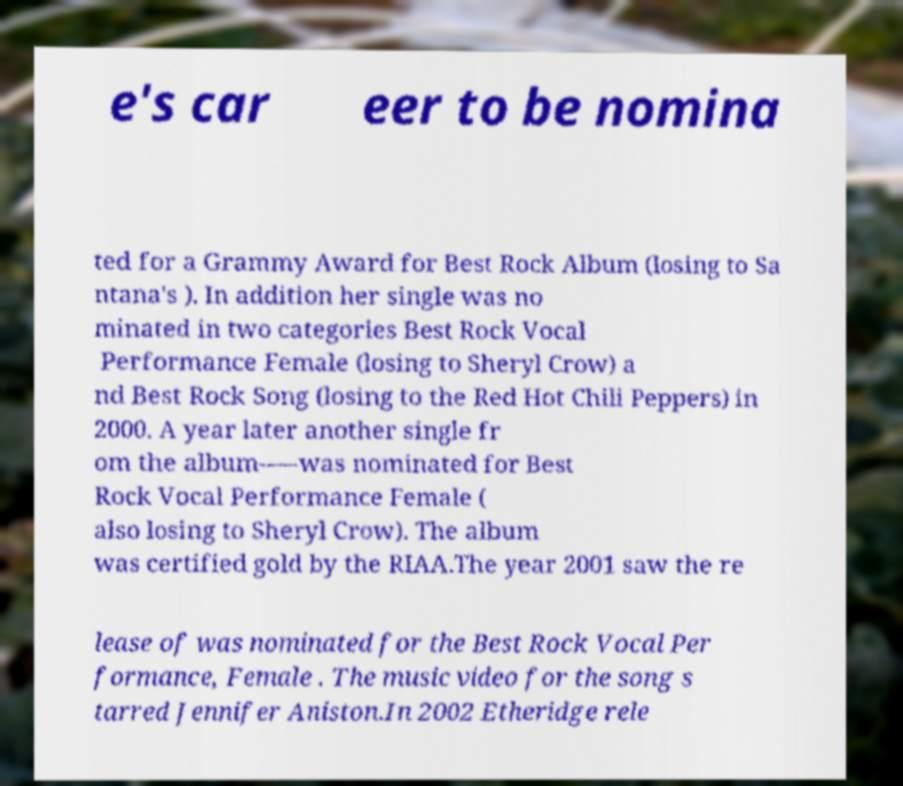Can you read and provide the text displayed in the image?This photo seems to have some interesting text. Can you extract and type it out for me? e's car eer to be nomina ted for a Grammy Award for Best Rock Album (losing to Sa ntana's ). In addition her single was no minated in two categories Best Rock Vocal Performance Female (losing to Sheryl Crow) a nd Best Rock Song (losing to the Red Hot Chili Peppers) in 2000. A year later another single fr om the album--—was nominated for Best Rock Vocal Performance Female ( also losing to Sheryl Crow). The album was certified gold by the RIAA.The year 2001 saw the re lease of was nominated for the Best Rock Vocal Per formance, Female . The music video for the song s tarred Jennifer Aniston.In 2002 Etheridge rele 